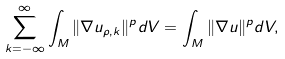<formula> <loc_0><loc_0><loc_500><loc_500>\sum _ { k = - \infty } ^ { \infty } \int _ { M } \| \nabla u _ { \rho , k } \| ^ { p } d V = \int _ { M } \| \nabla u \| ^ { p } d V ,</formula> 